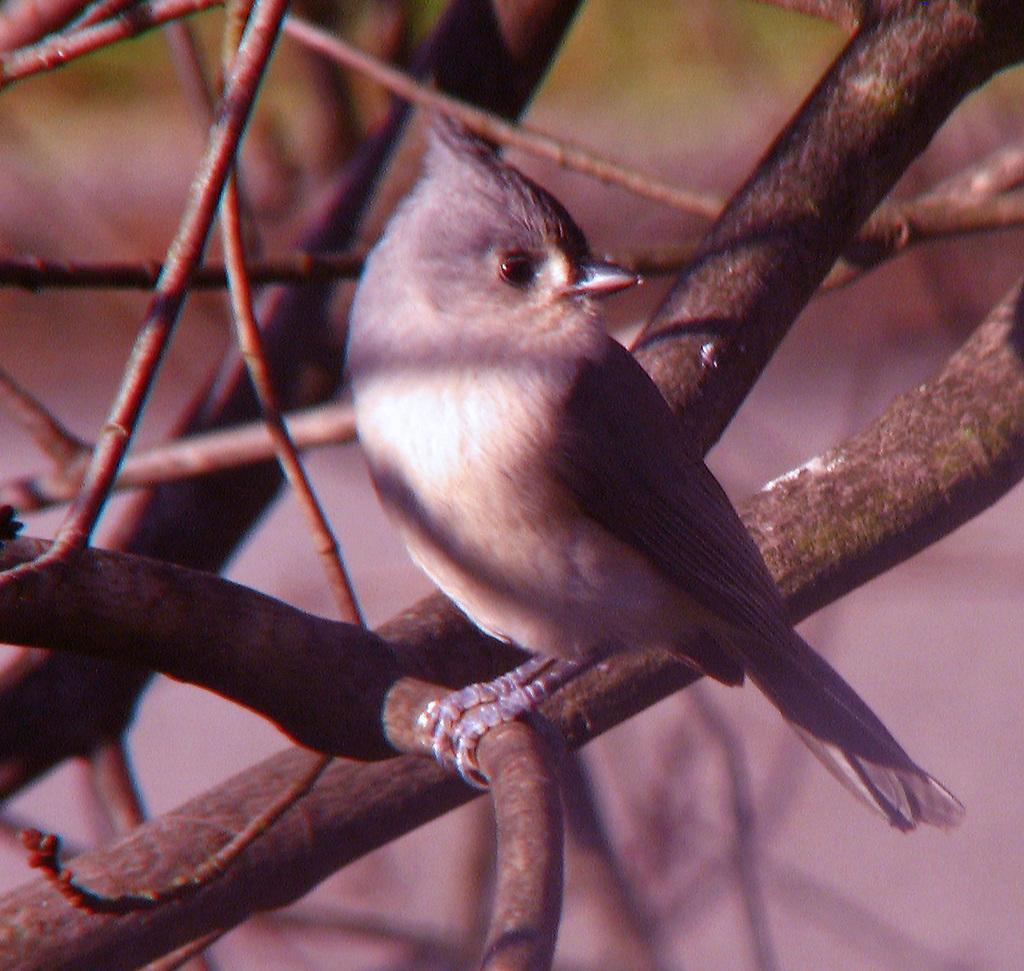Can you describe this image briefly? This is a zoomed in picture. In the center there is a bird standing on the branch of a tree. In the background we can see the branches and stems of the tree. 